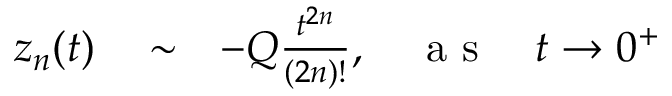<formula> <loc_0><loc_0><loc_500><loc_500>\begin{array} { r l r } { z _ { n } ( t ) } & \sim } & { - Q \frac { t ^ { 2 n } } { ( 2 n ) ! } , \quad a s \quad t \rightarrow 0 ^ { + } } \end{array}</formula> 